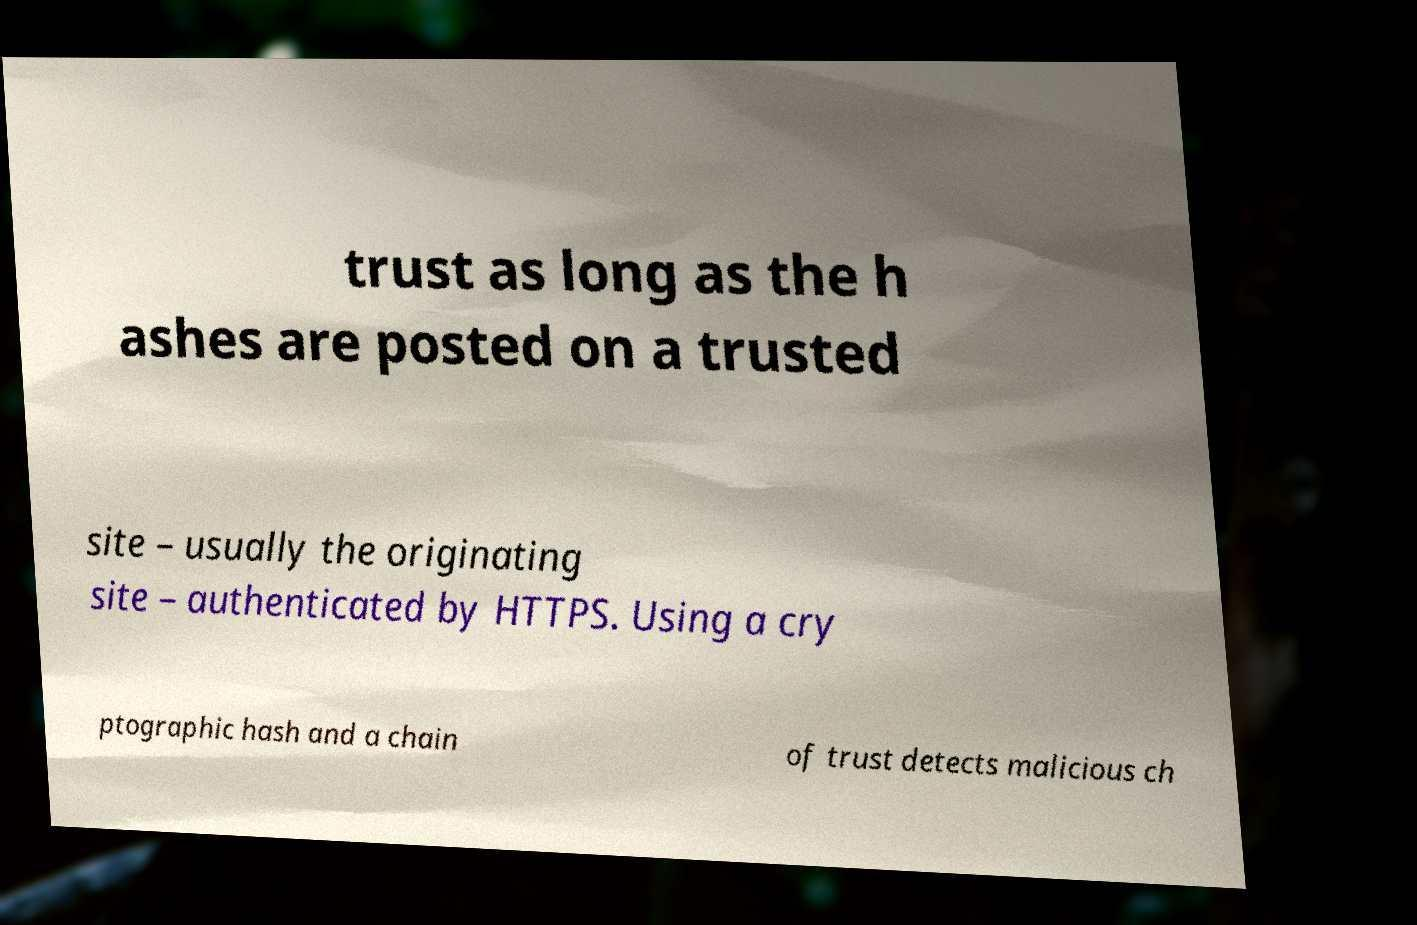Could you assist in decoding the text presented in this image and type it out clearly? trust as long as the h ashes are posted on a trusted site – usually the originating site – authenticated by HTTPS. Using a cry ptographic hash and a chain of trust detects malicious ch 